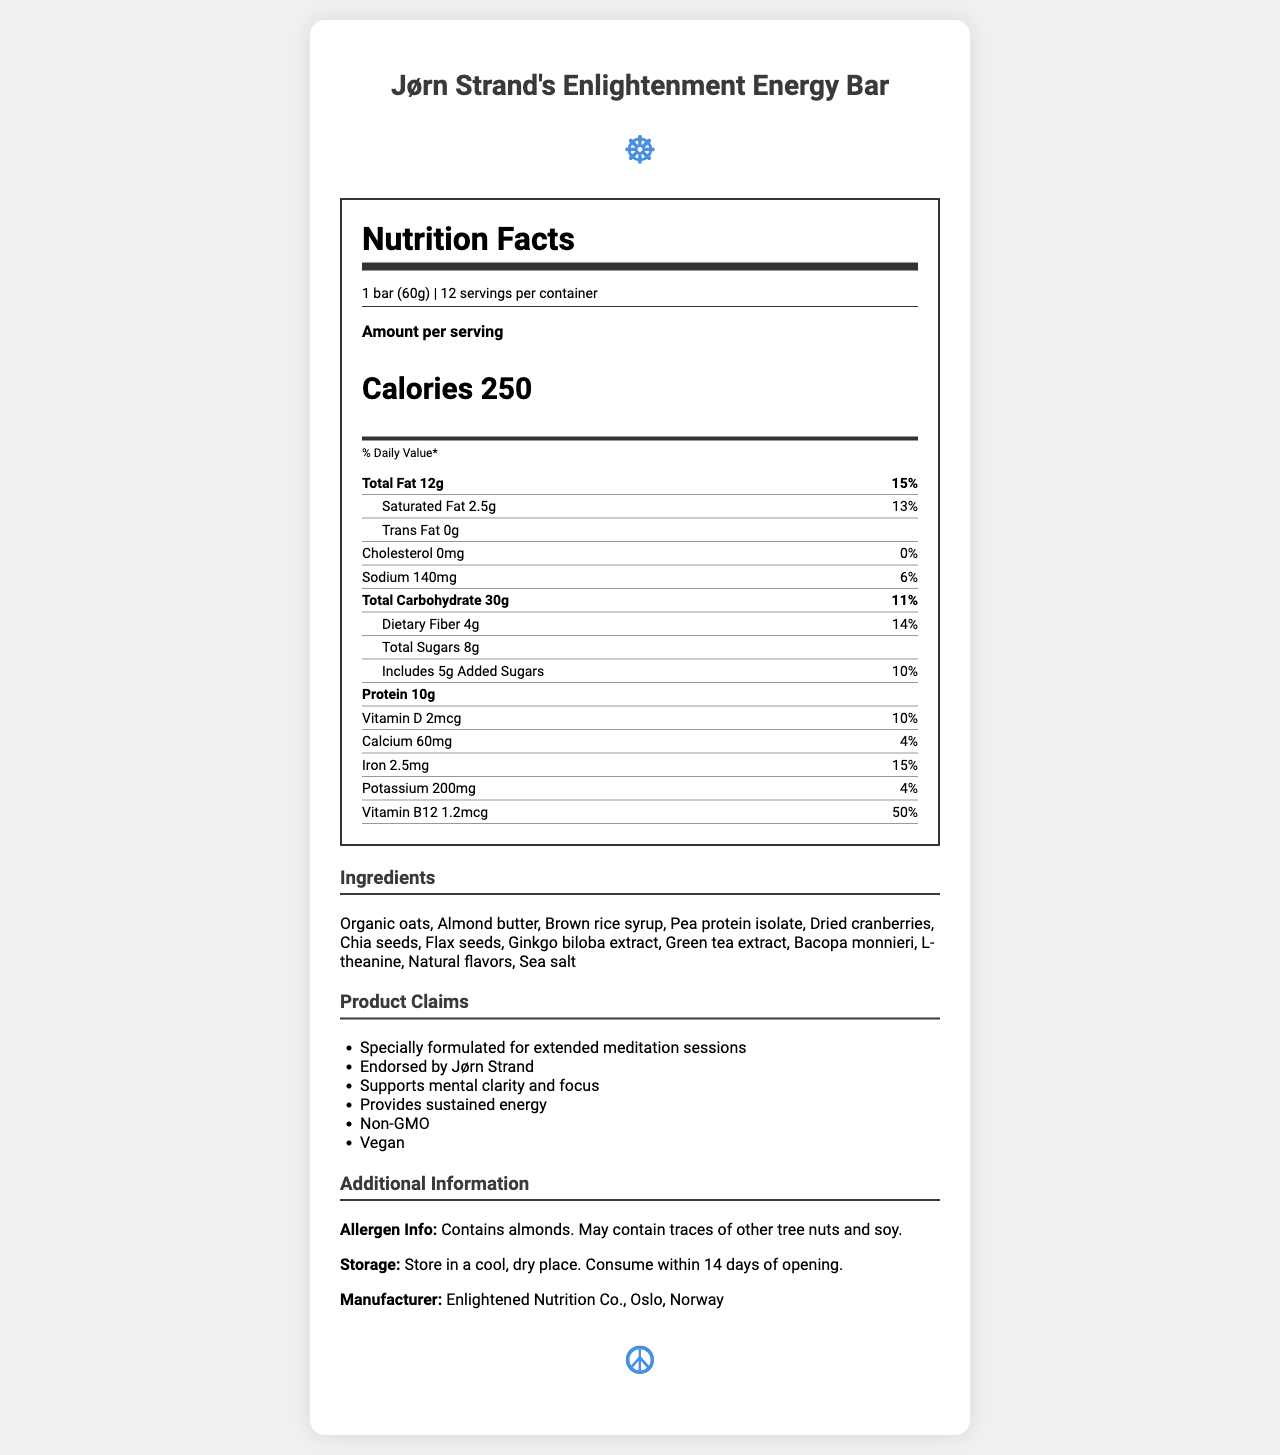what is the serving size? The serving size is explicitly mentioned in the document.
Answer: 1 bar (60g) how many servings per container are there? The document lists 12 servings per container.
Answer: 12 how many calories are in one serving of the energy bar? The document specifies that one serving contains 250 calories.
Answer: 250 how much total fat is in one bar? According to the document, each bar has 12g of total fat.
Answer: 12g what percentage of the daily value of saturated fat does one bar provide? The document states that one bar provides 13% of the daily value for saturated fat.
Answer: 13% how much dietary fiber is in each serving? The dietary fiber content per serving is 4g as indicated in the document.
Answer: 4g What are the top three ingredients listed? The document lists "Organic oats, Almond butter, Brown rice syrup" as the first three ingredients.
Answer: Organic oats, Almond butter, Brown rice syrup how much added sugars does the bar contain? The document indicates that the bar contains 5g of added sugars.
Answer: 5g which of the following ingredients is not included in the energy bar? 1. Pea protein isolate 2. Honey 3. Dried cranberries 4. Chia seeds Honey is not listed among the ingredients while the others are.
Answer: 2. Honey which vitamin is present in the highest percentage of daily value? A. Vitamin D B. Calcium C. Iron D. Vitamin B12 The document shows that Vitamin B12 is at 50% of the daily value, which is higher than the others listed.
Answer: D. Vitamin B12 does this product contain any cholesterol? The document shows that the cholesterol amount is 0mg with a daily value of 0%.
Answer: No is the product suitable for vegans? The document claims that the product is vegan.
Answer: Yes can you summarize the main idea of this document? The document covers detailed information on the nutritional content, ingredients, and health benefits of the energy bar, emphasizing its formulation for meditation.
Answer: The document provides the nutrition facts for "Jørn Strand's Enlightenment Energy Bar", including its ingredients, serving size, nutrient content, product claims, storage instructions, and manufacturer details. It highlights that the bar is specially formulated for extended meditation sessions to support mental clarity and focus. What is the exact amount of protein in the entire container? The document provides the protein amount per serving (10g) but does not explicitly state the total protein content for the entire container. One would need to multiply the per-serving value by the number of servings, but this is not given in the document itself.
Answer: Cannot be determined 